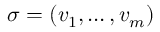Convert formula to latex. <formula><loc_0><loc_0><loc_500><loc_500>\sigma = ( v _ { 1 } , \dots , v _ { m } )</formula> 